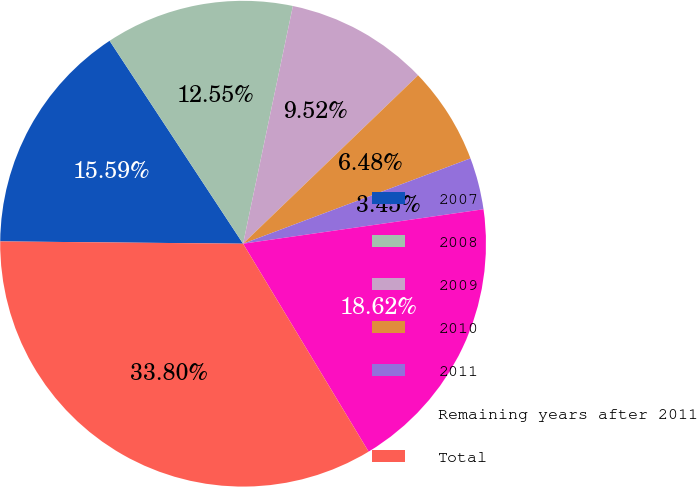<chart> <loc_0><loc_0><loc_500><loc_500><pie_chart><fcel>2007<fcel>2008<fcel>2009<fcel>2010<fcel>2011<fcel>Remaining years after 2011<fcel>Total<nl><fcel>15.59%<fcel>12.55%<fcel>9.52%<fcel>6.48%<fcel>3.45%<fcel>18.62%<fcel>33.8%<nl></chart> 